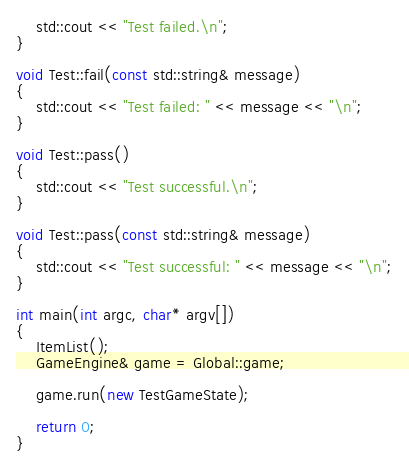<code> <loc_0><loc_0><loc_500><loc_500><_C++_>    std::cout << "Test failed.\n";
}

void Test::fail(const std::string& message)
{
    std::cout << "Test failed: " << message << "\n";
}

void Test::pass()
{
    std::cout << "Test successful.\n";
}

void Test::pass(const std::string& message)
{
    std::cout << "Test successful: " << message << "\n";
}

int main(int argc, char* argv[])
{
    ItemList();
    GameEngine& game = Global::game;

    game.run(new TestGameState);

    return 0;
}
</code> 